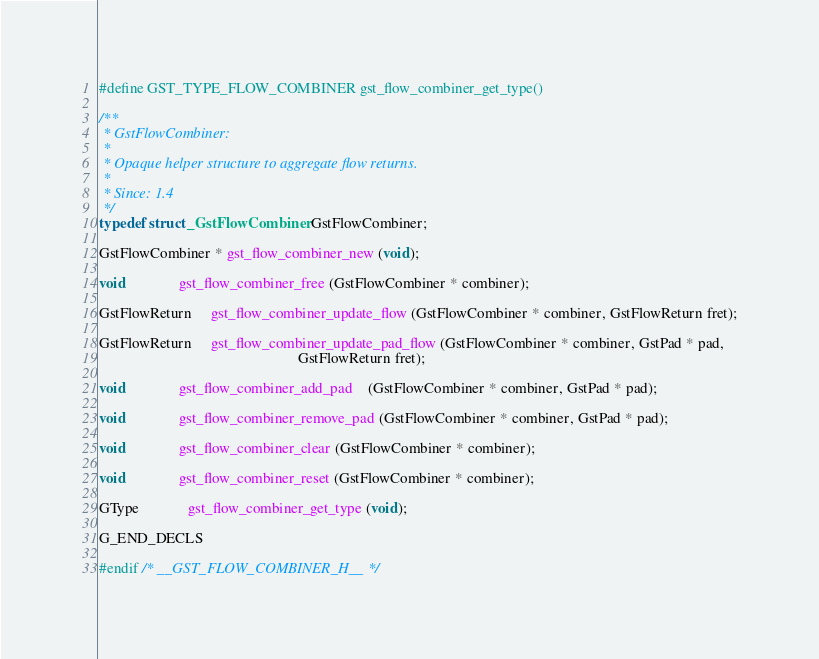<code> <loc_0><loc_0><loc_500><loc_500><_C_>
#define GST_TYPE_FLOW_COMBINER gst_flow_combiner_get_type()

/**
 * GstFlowCombiner:
 *
 * Opaque helper structure to aggregate flow returns.
 *
 * Since: 1.4
 */
typedef struct _GstFlowCombiner GstFlowCombiner;

GstFlowCombiner * gst_flow_combiner_new (void);

void              gst_flow_combiner_free (GstFlowCombiner * combiner);

GstFlowReturn     gst_flow_combiner_update_flow (GstFlowCombiner * combiner, GstFlowReturn fret);

GstFlowReturn     gst_flow_combiner_update_pad_flow (GstFlowCombiner * combiner, GstPad * pad,
                                                     GstFlowReturn fret);

void              gst_flow_combiner_add_pad    (GstFlowCombiner * combiner, GstPad * pad);

void              gst_flow_combiner_remove_pad (GstFlowCombiner * combiner, GstPad * pad);

void              gst_flow_combiner_clear (GstFlowCombiner * combiner);

void              gst_flow_combiner_reset (GstFlowCombiner * combiner);

GType             gst_flow_combiner_get_type (void);

G_END_DECLS

#endif /* __GST_FLOW_COMBINER_H__ */
</code> 